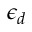Convert formula to latex. <formula><loc_0><loc_0><loc_500><loc_500>\epsilon _ { d }</formula> 